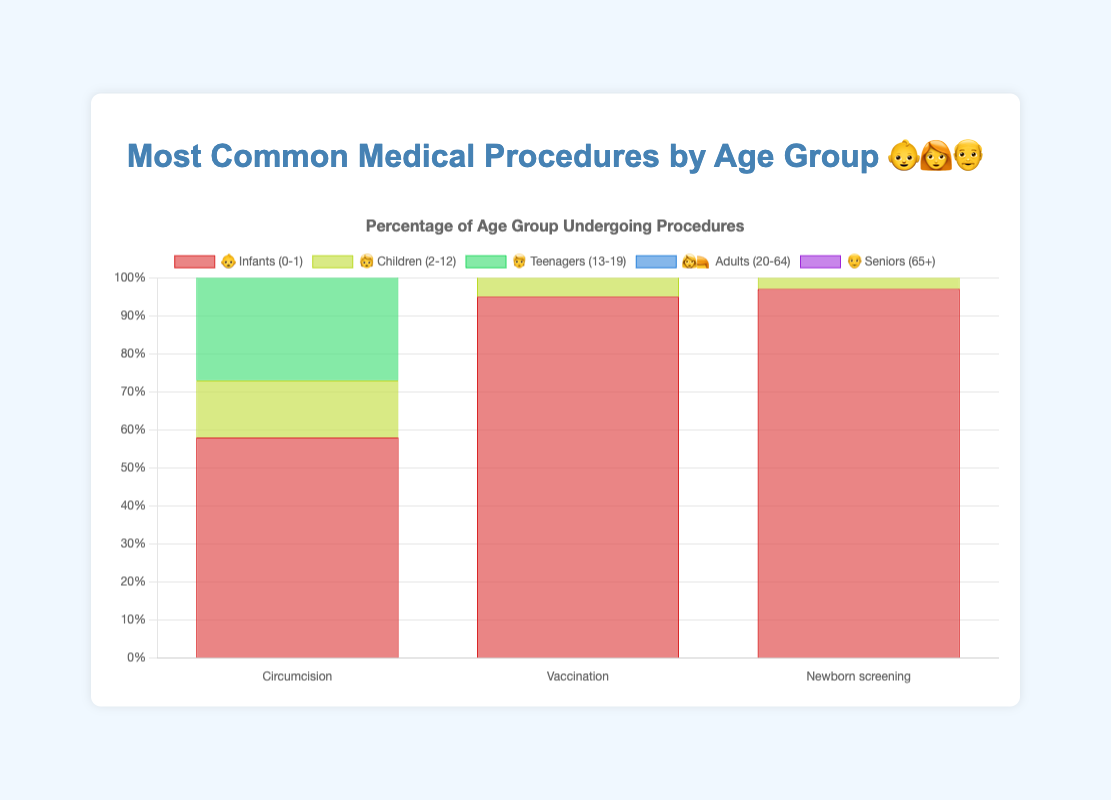What is the most common medical procedure for infants 👶? The chart shows three procedures for infants: Circumcision, Vaccination, and Newborn screening. Newborn screening has the highest percentage at 97%.
Answer: Newborn screening Which age group 👩‍🦰 or 👴 has a higher percentage of people undergoing Flu vaccination? Comparing the procedures, Flu vaccination is present in the Seniors (65+) group and has an 85% rate. In the Adults (20-64) group, this procedure is not listed. Thus, the Seniors (65+) group has the higher percentage.
Answer: Seniors (65+) What is the least common procedure for children 🧒? The chart lists three procedures for children: Tonsillectomy (15%), Dental fillings (40%), and Vision screening (75%). Tonsillectomy has the lowest percentage at 15%.
Answer: Tonsillectomy Which age group undergoes more frequent Vision screening 🧒 or Colonoscopy 👩‍🦰? Vision screening for Children (2-12) has a 75% rate, while Colonoscopy for Adults (20-64) has a 25% rate. Therefore, Vision screening is more frequent.
Answer: Vision screening How does the percentage of Vaccination for Infants 👶 compare to Flu vaccination for Seniors 👴? Vaccination for Infants is 95%, and Flu vaccination for Seniors is 85%. Vaccination for Infants is 10% higher than Flu vaccination for Seniors.
Answer: 10% higher Which age group has the highest percentage for Vision screening or Cholesterol screening? 🧒 👩‍🦰 Vision screening in Children (2-12) is 75%, while Cholesterol screening in Adults (20-64) is 70%. So, Vision screening in Children has the highest percentage.
Answer: Vision screening What is the sum of the percentages for procedures in the Teenagers category 🧑? Adding the percentages for the procedures in Teenagers: Wisdom teeth removal (35%) + Acne treatment (30%) + Sports physicals (60%) equals 125%.
Answer: 125% Compare the percentage difference between Newborn screening 👶 and Hip replacement 👴. Newborn screening has a 97% rate, and Hip replacement has a 10% rate. The percentage difference is 97% - 10% = 87%.
Answer: 87% Which procedure has the highest percentage across all age groups? Reviewing all procedures, Newborn screening in Infants has the highest percentage at 97%.
Answer: Newborn screening Which age group has the lowest rate for any medical procedure? Considering the lowest values for each group: Infants: 58% (Circumcision), Children: 15% (Tonsillectomy), Teenagers: 30% (Acne treatment), Adults: 25% (Colonoscopy), Seniors: 10% (Hip replacement). The lowest rate overall is Seniors' Hip replacement at 10%.
Answer: Seniors (Hip replacement) 